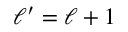<formula> <loc_0><loc_0><loc_500><loc_500>\ell ^ { \prime } = \ell + 1</formula> 